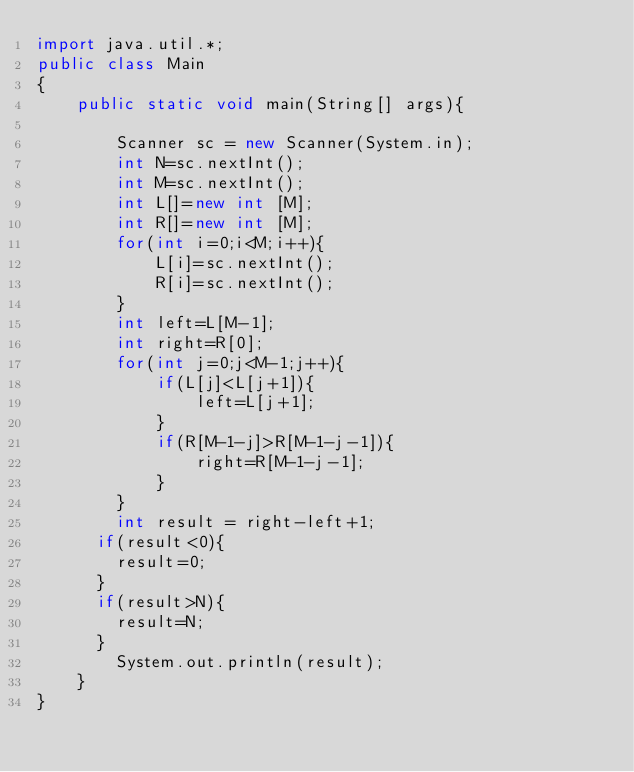Convert code to text. <code><loc_0><loc_0><loc_500><loc_500><_Java_>import java.util.*;
public class Main
{
    public static void main(String[] args){

        Scanner sc = new Scanner(System.in);
        int N=sc.nextInt();
        int M=sc.nextInt();
        int L[]=new int [M];
        int R[]=new int [M];
        for(int i=0;i<M;i++){
            L[i]=sc.nextInt();
            R[i]=sc.nextInt();
        }
        int left=L[M-1];
        int right=R[0];
        for(int j=0;j<M-1;j++){
            if(L[j]<L[j+1]){
                left=L[j+1];
            }
            if(R[M-1-j]>R[M-1-j-1]){
                right=R[M-1-j-1];
            }
        }
        int result = right-left+1;
      if(result<0){
        result=0;
      }
      if(result>N){
        result=N;
      }
        System.out.println(result);
    }
}</code> 